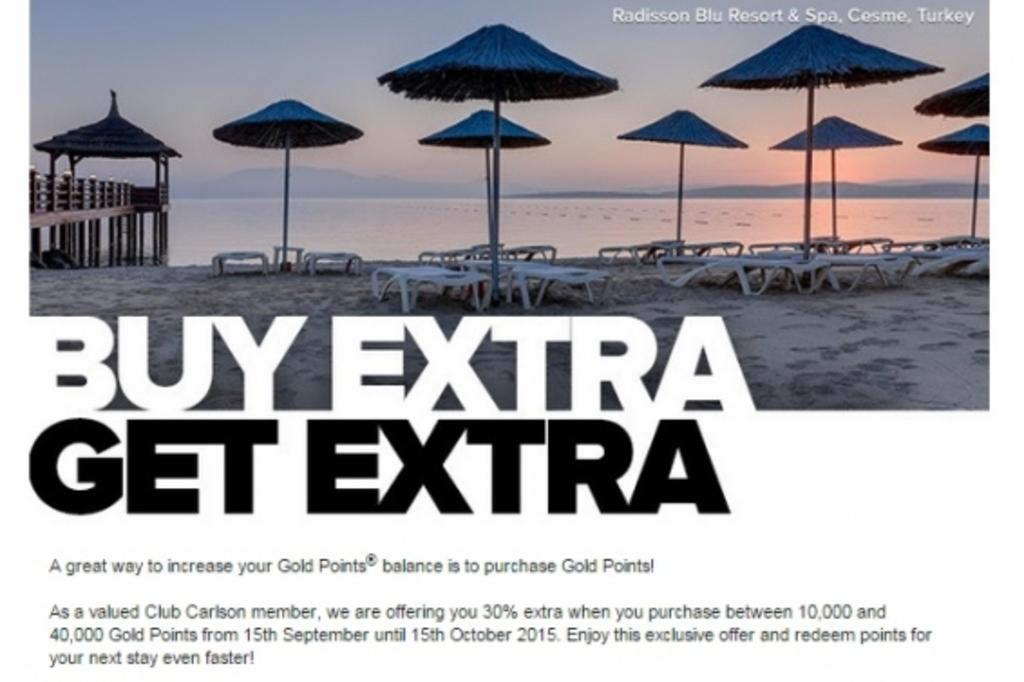What type of structures are located on the beach sand in the image? There are shacks on the beach sand in the image. What is in front of the shacks? There is water in front of the shacks. What can be seen in the distance in the image? There are mountains visible in the image. What is written or depicted in the image? There is some text written in the image. What type of food is being cooked on the beach in the image? There is no indication of cooking or food preparation in the image. How many suns are visible in the sky in the image? There is only one sun visible in the sky in the image. 